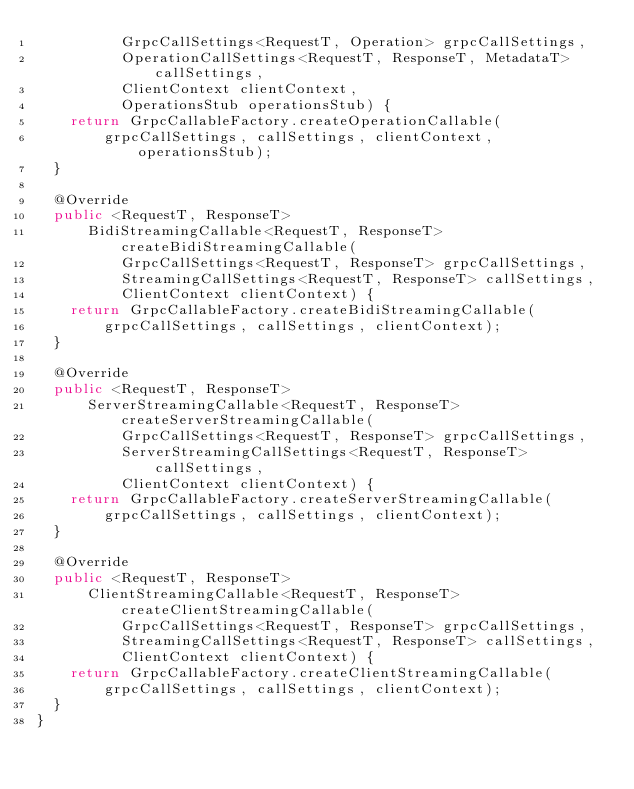<code> <loc_0><loc_0><loc_500><loc_500><_Java_>          GrpcCallSettings<RequestT, Operation> grpcCallSettings,
          OperationCallSettings<RequestT, ResponseT, MetadataT> callSettings,
          ClientContext clientContext,
          OperationsStub operationsStub) {
    return GrpcCallableFactory.createOperationCallable(
        grpcCallSettings, callSettings, clientContext, operationsStub);
  }

  @Override
  public <RequestT, ResponseT>
      BidiStreamingCallable<RequestT, ResponseT> createBidiStreamingCallable(
          GrpcCallSettings<RequestT, ResponseT> grpcCallSettings,
          StreamingCallSettings<RequestT, ResponseT> callSettings,
          ClientContext clientContext) {
    return GrpcCallableFactory.createBidiStreamingCallable(
        grpcCallSettings, callSettings, clientContext);
  }

  @Override
  public <RequestT, ResponseT>
      ServerStreamingCallable<RequestT, ResponseT> createServerStreamingCallable(
          GrpcCallSettings<RequestT, ResponseT> grpcCallSettings,
          ServerStreamingCallSettings<RequestT, ResponseT> callSettings,
          ClientContext clientContext) {
    return GrpcCallableFactory.createServerStreamingCallable(
        grpcCallSettings, callSettings, clientContext);
  }

  @Override
  public <RequestT, ResponseT>
      ClientStreamingCallable<RequestT, ResponseT> createClientStreamingCallable(
          GrpcCallSettings<RequestT, ResponseT> grpcCallSettings,
          StreamingCallSettings<RequestT, ResponseT> callSettings,
          ClientContext clientContext) {
    return GrpcCallableFactory.createClientStreamingCallable(
        grpcCallSettings, callSettings, clientContext);
  }
}
</code> 